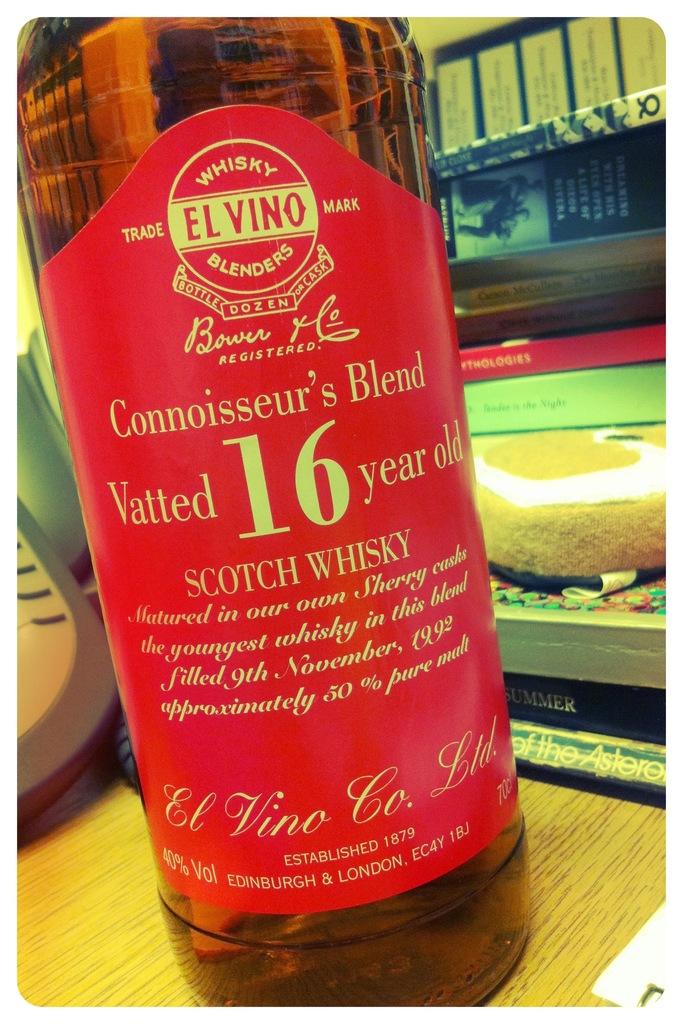How many years was this vatted?
Keep it short and to the point. 16. What type of whisky is this?
Keep it short and to the point. Scotch. 